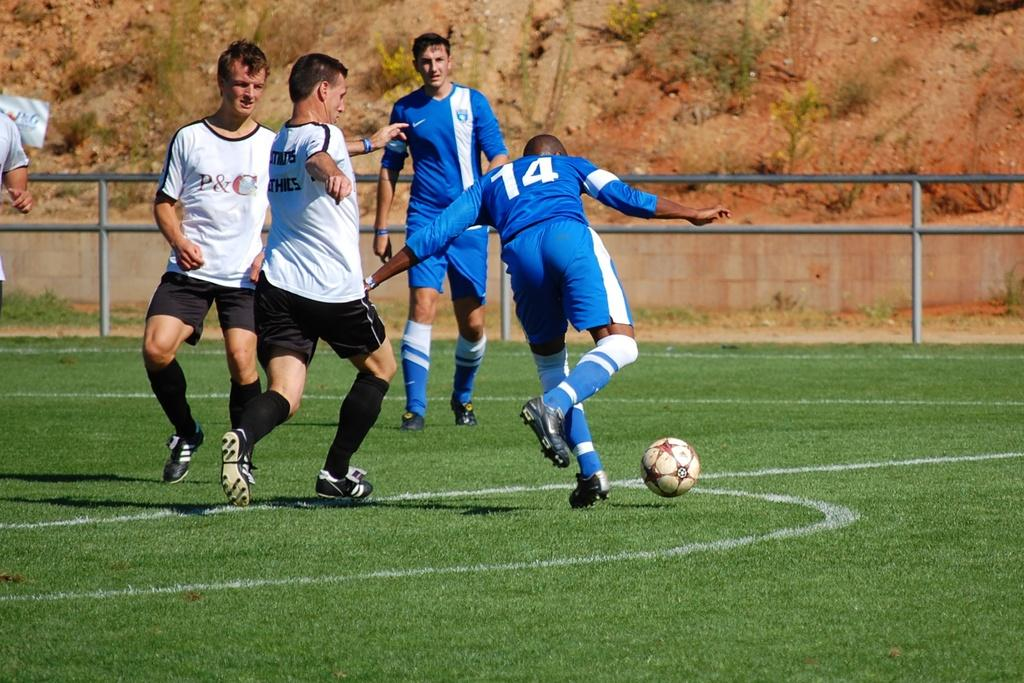Provide a one-sentence caption for the provided image. Number 14 on the soccer field is getting ready to kick the ball. 